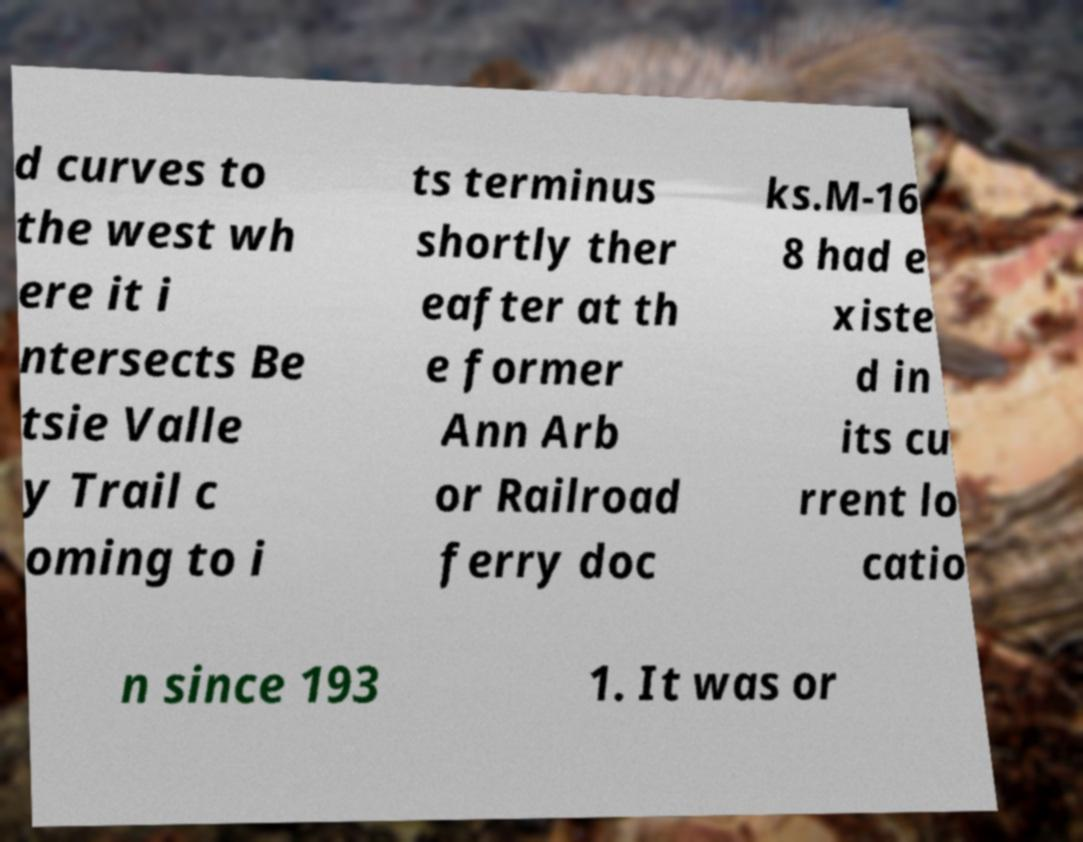Can you accurately transcribe the text from the provided image for me? d curves to the west wh ere it i ntersects Be tsie Valle y Trail c oming to i ts terminus shortly ther eafter at th e former Ann Arb or Railroad ferry doc ks.M-16 8 had e xiste d in its cu rrent lo catio n since 193 1. It was or 